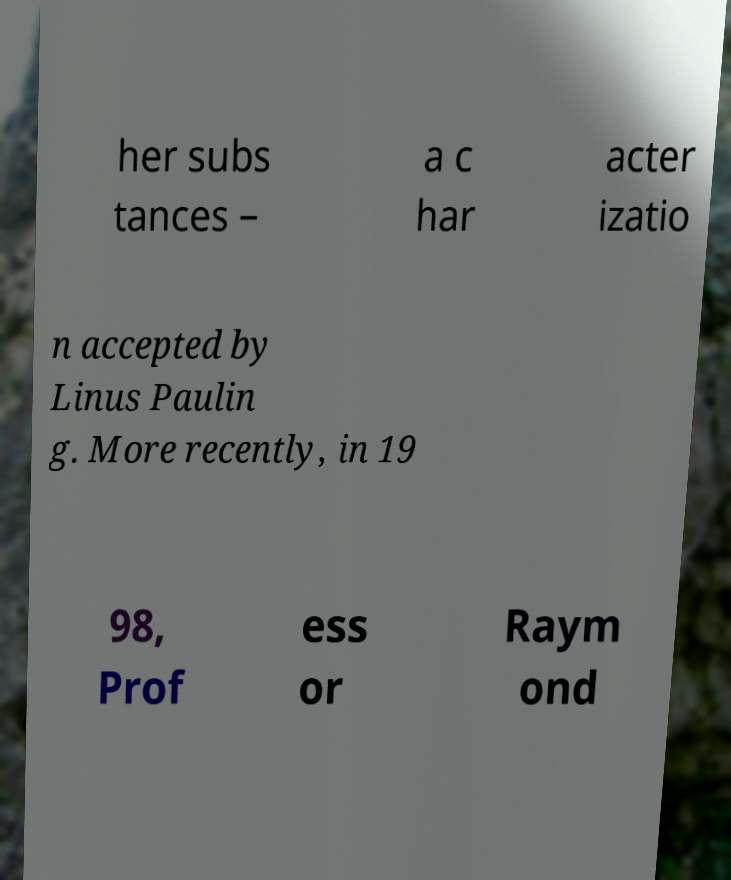Can you accurately transcribe the text from the provided image for me? her subs tances – a c har acter izatio n accepted by Linus Paulin g. More recently, in 19 98, Prof ess or Raym ond 